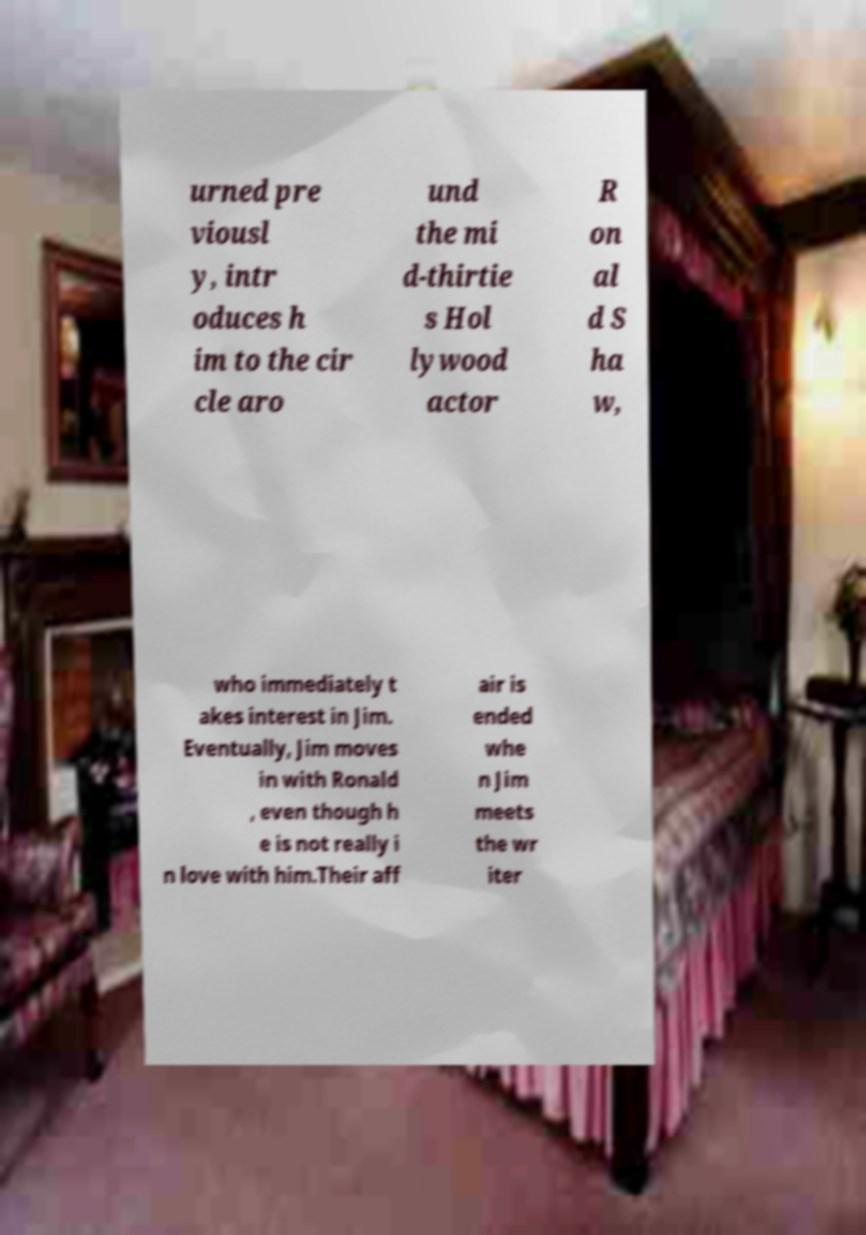What messages or text are displayed in this image? I need them in a readable, typed format. urned pre viousl y, intr oduces h im to the cir cle aro und the mi d-thirtie s Hol lywood actor R on al d S ha w, who immediately t akes interest in Jim. Eventually, Jim moves in with Ronald , even though h e is not really i n love with him.Their aff air is ended whe n Jim meets the wr iter 